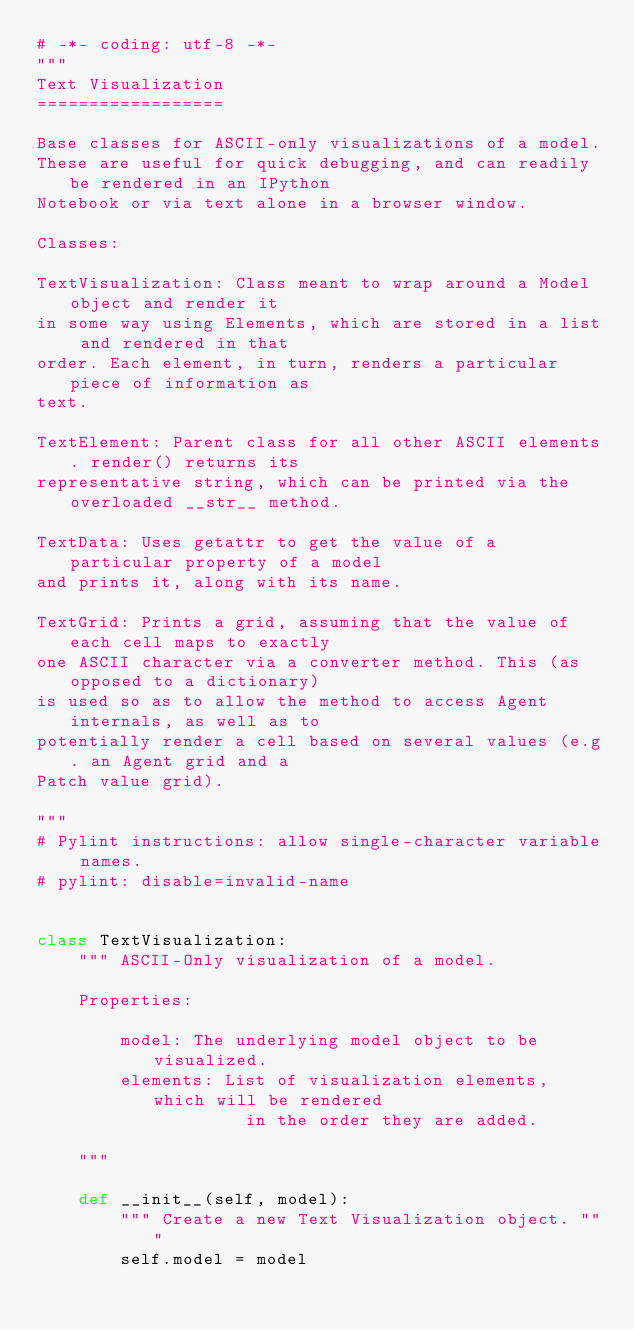Convert code to text. <code><loc_0><loc_0><loc_500><loc_500><_Python_># -*- coding: utf-8 -*-
"""
Text Visualization
==================

Base classes for ASCII-only visualizations of a model.
These are useful for quick debugging, and can readily be rendered in an IPython
Notebook or via text alone in a browser window.

Classes:

TextVisualization: Class meant to wrap around a Model object and render it
in some way using Elements, which are stored in a list and rendered in that
order. Each element, in turn, renders a particular piece of information as
text.

TextElement: Parent class for all other ASCII elements. render() returns its
representative string, which can be printed via the overloaded __str__ method.

TextData: Uses getattr to get the value of a particular property of a model
and prints it, along with its name.

TextGrid: Prints a grid, assuming that the value of each cell maps to exactly
one ASCII character via a converter method. This (as opposed to a dictionary)
is used so as to allow the method to access Agent internals, as well as to
potentially render a cell based on several values (e.g. an Agent grid and a
Patch value grid).

"""
# Pylint instructions: allow single-character variable names.
# pylint: disable=invalid-name


class TextVisualization:
    """ ASCII-Only visualization of a model.

    Properties:

        model: The underlying model object to be visualized.
        elements: List of visualization elements, which will be rendered
                    in the order they are added.

    """

    def __init__(self, model):
        """ Create a new Text Visualization object. """
        self.model = model</code> 